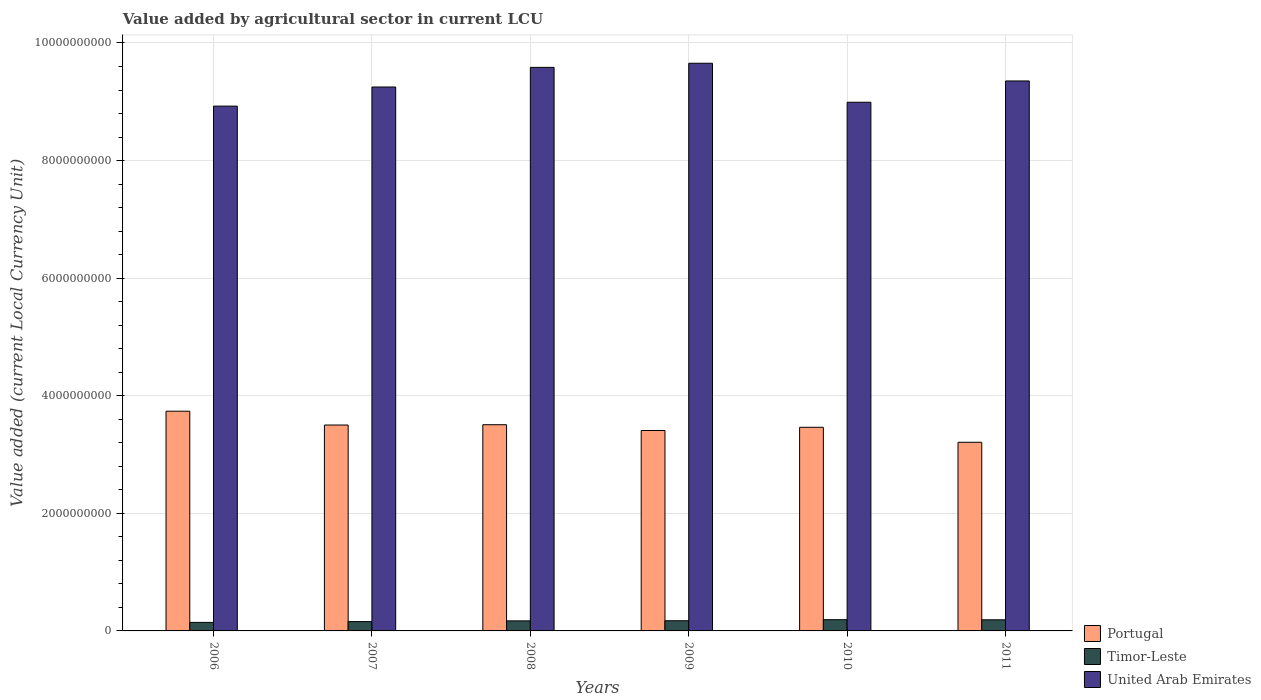How many different coloured bars are there?
Offer a terse response. 3. How many groups of bars are there?
Ensure brevity in your answer.  6. Are the number of bars per tick equal to the number of legend labels?
Ensure brevity in your answer.  Yes. Are the number of bars on each tick of the X-axis equal?
Give a very brief answer. Yes. What is the value added by agricultural sector in Portugal in 2009?
Offer a terse response. 3.41e+09. Across all years, what is the maximum value added by agricultural sector in Timor-Leste?
Make the answer very short. 1.91e+08. Across all years, what is the minimum value added by agricultural sector in Timor-Leste?
Make the answer very short. 1.45e+08. In which year was the value added by agricultural sector in United Arab Emirates maximum?
Give a very brief answer. 2009. What is the total value added by agricultural sector in Portugal in the graph?
Give a very brief answer. 2.08e+1. What is the difference between the value added by agricultural sector in Timor-Leste in 2007 and that in 2010?
Provide a succinct answer. -3.20e+07. What is the difference between the value added by agricultural sector in Timor-Leste in 2008 and the value added by agricultural sector in United Arab Emirates in 2009?
Give a very brief answer. -9.48e+09. What is the average value added by agricultural sector in United Arab Emirates per year?
Provide a short and direct response. 9.29e+09. In the year 2006, what is the difference between the value added by agricultural sector in Timor-Leste and value added by agricultural sector in Portugal?
Provide a short and direct response. -3.59e+09. In how many years, is the value added by agricultural sector in Timor-Leste greater than 2000000000 LCU?
Your response must be concise. 0. What is the ratio of the value added by agricultural sector in Portugal in 2007 to that in 2010?
Your response must be concise. 1.01. Is the difference between the value added by agricultural sector in Timor-Leste in 2006 and 2010 greater than the difference between the value added by agricultural sector in Portugal in 2006 and 2010?
Keep it short and to the point. No. What is the difference between the highest and the second highest value added by agricultural sector in United Arab Emirates?
Offer a terse response. 7.00e+07. What is the difference between the highest and the lowest value added by agricultural sector in United Arab Emirates?
Offer a terse response. 7.29e+08. What does the 3rd bar from the left in 2008 represents?
Your answer should be compact. United Arab Emirates. What does the 1st bar from the right in 2009 represents?
Keep it short and to the point. United Arab Emirates. Is it the case that in every year, the sum of the value added by agricultural sector in Timor-Leste and value added by agricultural sector in United Arab Emirates is greater than the value added by agricultural sector in Portugal?
Provide a succinct answer. Yes. How many years are there in the graph?
Provide a short and direct response. 6. Where does the legend appear in the graph?
Your answer should be very brief. Bottom right. How many legend labels are there?
Give a very brief answer. 3. What is the title of the graph?
Your answer should be very brief. Value added by agricultural sector in current LCU. What is the label or title of the X-axis?
Provide a short and direct response. Years. What is the label or title of the Y-axis?
Offer a terse response. Value added (current Local Currency Unit). What is the Value added (current Local Currency Unit) of Portugal in 2006?
Provide a short and direct response. 3.74e+09. What is the Value added (current Local Currency Unit) of Timor-Leste in 2006?
Provide a succinct answer. 1.45e+08. What is the Value added (current Local Currency Unit) in United Arab Emirates in 2006?
Provide a short and direct response. 8.93e+09. What is the Value added (current Local Currency Unit) in Portugal in 2007?
Keep it short and to the point. 3.50e+09. What is the Value added (current Local Currency Unit) of Timor-Leste in 2007?
Your response must be concise. 1.59e+08. What is the Value added (current Local Currency Unit) of United Arab Emirates in 2007?
Provide a succinct answer. 9.25e+09. What is the Value added (current Local Currency Unit) of Portugal in 2008?
Your answer should be very brief. 3.51e+09. What is the Value added (current Local Currency Unit) of Timor-Leste in 2008?
Provide a succinct answer. 1.71e+08. What is the Value added (current Local Currency Unit) of United Arab Emirates in 2008?
Your answer should be compact. 9.58e+09. What is the Value added (current Local Currency Unit) of Portugal in 2009?
Provide a succinct answer. 3.41e+09. What is the Value added (current Local Currency Unit) of Timor-Leste in 2009?
Ensure brevity in your answer.  1.73e+08. What is the Value added (current Local Currency Unit) in United Arab Emirates in 2009?
Your response must be concise. 9.66e+09. What is the Value added (current Local Currency Unit) of Portugal in 2010?
Offer a terse response. 3.46e+09. What is the Value added (current Local Currency Unit) in Timor-Leste in 2010?
Ensure brevity in your answer.  1.91e+08. What is the Value added (current Local Currency Unit) of United Arab Emirates in 2010?
Offer a terse response. 8.99e+09. What is the Value added (current Local Currency Unit) of Portugal in 2011?
Offer a terse response. 3.21e+09. What is the Value added (current Local Currency Unit) in Timor-Leste in 2011?
Provide a succinct answer. 1.89e+08. What is the Value added (current Local Currency Unit) in United Arab Emirates in 2011?
Your response must be concise. 9.35e+09. Across all years, what is the maximum Value added (current Local Currency Unit) in Portugal?
Your answer should be compact. 3.74e+09. Across all years, what is the maximum Value added (current Local Currency Unit) of Timor-Leste?
Keep it short and to the point. 1.91e+08. Across all years, what is the maximum Value added (current Local Currency Unit) of United Arab Emirates?
Your response must be concise. 9.66e+09. Across all years, what is the minimum Value added (current Local Currency Unit) of Portugal?
Ensure brevity in your answer.  3.21e+09. Across all years, what is the minimum Value added (current Local Currency Unit) in Timor-Leste?
Keep it short and to the point. 1.45e+08. Across all years, what is the minimum Value added (current Local Currency Unit) in United Arab Emirates?
Your answer should be compact. 8.93e+09. What is the total Value added (current Local Currency Unit) of Portugal in the graph?
Offer a very short reply. 2.08e+1. What is the total Value added (current Local Currency Unit) in Timor-Leste in the graph?
Ensure brevity in your answer.  1.03e+09. What is the total Value added (current Local Currency Unit) of United Arab Emirates in the graph?
Provide a succinct answer. 5.58e+1. What is the difference between the Value added (current Local Currency Unit) of Portugal in 2006 and that in 2007?
Your answer should be very brief. 2.35e+08. What is the difference between the Value added (current Local Currency Unit) of Timor-Leste in 2006 and that in 2007?
Provide a succinct answer. -1.40e+07. What is the difference between the Value added (current Local Currency Unit) in United Arab Emirates in 2006 and that in 2007?
Your answer should be compact. -3.25e+08. What is the difference between the Value added (current Local Currency Unit) of Portugal in 2006 and that in 2008?
Offer a terse response. 2.29e+08. What is the difference between the Value added (current Local Currency Unit) in Timor-Leste in 2006 and that in 2008?
Your answer should be compact. -2.60e+07. What is the difference between the Value added (current Local Currency Unit) in United Arab Emirates in 2006 and that in 2008?
Your answer should be very brief. -6.59e+08. What is the difference between the Value added (current Local Currency Unit) in Portugal in 2006 and that in 2009?
Your answer should be compact. 3.28e+08. What is the difference between the Value added (current Local Currency Unit) in Timor-Leste in 2006 and that in 2009?
Offer a terse response. -2.80e+07. What is the difference between the Value added (current Local Currency Unit) in United Arab Emirates in 2006 and that in 2009?
Your answer should be compact. -7.29e+08. What is the difference between the Value added (current Local Currency Unit) of Portugal in 2006 and that in 2010?
Keep it short and to the point. 2.73e+08. What is the difference between the Value added (current Local Currency Unit) of Timor-Leste in 2006 and that in 2010?
Ensure brevity in your answer.  -4.60e+07. What is the difference between the Value added (current Local Currency Unit) in United Arab Emirates in 2006 and that in 2010?
Offer a terse response. -6.60e+07. What is the difference between the Value added (current Local Currency Unit) of Portugal in 2006 and that in 2011?
Give a very brief answer. 5.28e+08. What is the difference between the Value added (current Local Currency Unit) in Timor-Leste in 2006 and that in 2011?
Your response must be concise. -4.40e+07. What is the difference between the Value added (current Local Currency Unit) in United Arab Emirates in 2006 and that in 2011?
Provide a succinct answer. -4.28e+08. What is the difference between the Value added (current Local Currency Unit) of Portugal in 2007 and that in 2008?
Your answer should be compact. -5.42e+06. What is the difference between the Value added (current Local Currency Unit) of Timor-Leste in 2007 and that in 2008?
Your answer should be very brief. -1.20e+07. What is the difference between the Value added (current Local Currency Unit) of United Arab Emirates in 2007 and that in 2008?
Your response must be concise. -3.34e+08. What is the difference between the Value added (current Local Currency Unit) in Portugal in 2007 and that in 2009?
Your answer should be very brief. 9.31e+07. What is the difference between the Value added (current Local Currency Unit) in Timor-Leste in 2007 and that in 2009?
Your response must be concise. -1.40e+07. What is the difference between the Value added (current Local Currency Unit) in United Arab Emirates in 2007 and that in 2009?
Make the answer very short. -4.04e+08. What is the difference between the Value added (current Local Currency Unit) in Portugal in 2007 and that in 2010?
Provide a short and direct response. 3.86e+07. What is the difference between the Value added (current Local Currency Unit) in Timor-Leste in 2007 and that in 2010?
Ensure brevity in your answer.  -3.20e+07. What is the difference between the Value added (current Local Currency Unit) of United Arab Emirates in 2007 and that in 2010?
Your response must be concise. 2.59e+08. What is the difference between the Value added (current Local Currency Unit) in Portugal in 2007 and that in 2011?
Provide a short and direct response. 2.93e+08. What is the difference between the Value added (current Local Currency Unit) of Timor-Leste in 2007 and that in 2011?
Ensure brevity in your answer.  -3.00e+07. What is the difference between the Value added (current Local Currency Unit) of United Arab Emirates in 2007 and that in 2011?
Offer a terse response. -1.03e+08. What is the difference between the Value added (current Local Currency Unit) in Portugal in 2008 and that in 2009?
Give a very brief answer. 9.85e+07. What is the difference between the Value added (current Local Currency Unit) in Timor-Leste in 2008 and that in 2009?
Offer a terse response. -2.00e+06. What is the difference between the Value added (current Local Currency Unit) in United Arab Emirates in 2008 and that in 2009?
Your answer should be very brief. -7.00e+07. What is the difference between the Value added (current Local Currency Unit) in Portugal in 2008 and that in 2010?
Offer a terse response. 4.40e+07. What is the difference between the Value added (current Local Currency Unit) in Timor-Leste in 2008 and that in 2010?
Keep it short and to the point. -2.00e+07. What is the difference between the Value added (current Local Currency Unit) in United Arab Emirates in 2008 and that in 2010?
Your answer should be very brief. 5.93e+08. What is the difference between the Value added (current Local Currency Unit) in Portugal in 2008 and that in 2011?
Make the answer very short. 2.99e+08. What is the difference between the Value added (current Local Currency Unit) in Timor-Leste in 2008 and that in 2011?
Give a very brief answer. -1.80e+07. What is the difference between the Value added (current Local Currency Unit) in United Arab Emirates in 2008 and that in 2011?
Your answer should be very brief. 2.31e+08. What is the difference between the Value added (current Local Currency Unit) of Portugal in 2009 and that in 2010?
Provide a succinct answer. -5.45e+07. What is the difference between the Value added (current Local Currency Unit) in Timor-Leste in 2009 and that in 2010?
Offer a terse response. -1.80e+07. What is the difference between the Value added (current Local Currency Unit) of United Arab Emirates in 2009 and that in 2010?
Keep it short and to the point. 6.63e+08. What is the difference between the Value added (current Local Currency Unit) of Portugal in 2009 and that in 2011?
Keep it short and to the point. 2.00e+08. What is the difference between the Value added (current Local Currency Unit) of Timor-Leste in 2009 and that in 2011?
Keep it short and to the point. -1.60e+07. What is the difference between the Value added (current Local Currency Unit) of United Arab Emirates in 2009 and that in 2011?
Make the answer very short. 3.01e+08. What is the difference between the Value added (current Local Currency Unit) in Portugal in 2010 and that in 2011?
Make the answer very short. 2.55e+08. What is the difference between the Value added (current Local Currency Unit) in United Arab Emirates in 2010 and that in 2011?
Your response must be concise. -3.62e+08. What is the difference between the Value added (current Local Currency Unit) in Portugal in 2006 and the Value added (current Local Currency Unit) in Timor-Leste in 2007?
Make the answer very short. 3.58e+09. What is the difference between the Value added (current Local Currency Unit) in Portugal in 2006 and the Value added (current Local Currency Unit) in United Arab Emirates in 2007?
Give a very brief answer. -5.51e+09. What is the difference between the Value added (current Local Currency Unit) of Timor-Leste in 2006 and the Value added (current Local Currency Unit) of United Arab Emirates in 2007?
Ensure brevity in your answer.  -9.11e+09. What is the difference between the Value added (current Local Currency Unit) in Portugal in 2006 and the Value added (current Local Currency Unit) in Timor-Leste in 2008?
Provide a succinct answer. 3.57e+09. What is the difference between the Value added (current Local Currency Unit) of Portugal in 2006 and the Value added (current Local Currency Unit) of United Arab Emirates in 2008?
Ensure brevity in your answer.  -5.85e+09. What is the difference between the Value added (current Local Currency Unit) in Timor-Leste in 2006 and the Value added (current Local Currency Unit) in United Arab Emirates in 2008?
Give a very brief answer. -9.44e+09. What is the difference between the Value added (current Local Currency Unit) in Portugal in 2006 and the Value added (current Local Currency Unit) in Timor-Leste in 2009?
Your answer should be very brief. 3.56e+09. What is the difference between the Value added (current Local Currency Unit) in Portugal in 2006 and the Value added (current Local Currency Unit) in United Arab Emirates in 2009?
Offer a very short reply. -5.92e+09. What is the difference between the Value added (current Local Currency Unit) in Timor-Leste in 2006 and the Value added (current Local Currency Unit) in United Arab Emirates in 2009?
Keep it short and to the point. -9.51e+09. What is the difference between the Value added (current Local Currency Unit) in Portugal in 2006 and the Value added (current Local Currency Unit) in Timor-Leste in 2010?
Offer a terse response. 3.55e+09. What is the difference between the Value added (current Local Currency Unit) in Portugal in 2006 and the Value added (current Local Currency Unit) in United Arab Emirates in 2010?
Your answer should be very brief. -5.26e+09. What is the difference between the Value added (current Local Currency Unit) in Timor-Leste in 2006 and the Value added (current Local Currency Unit) in United Arab Emirates in 2010?
Make the answer very short. -8.85e+09. What is the difference between the Value added (current Local Currency Unit) in Portugal in 2006 and the Value added (current Local Currency Unit) in Timor-Leste in 2011?
Your answer should be compact. 3.55e+09. What is the difference between the Value added (current Local Currency Unit) of Portugal in 2006 and the Value added (current Local Currency Unit) of United Arab Emirates in 2011?
Offer a terse response. -5.62e+09. What is the difference between the Value added (current Local Currency Unit) in Timor-Leste in 2006 and the Value added (current Local Currency Unit) in United Arab Emirates in 2011?
Offer a very short reply. -9.21e+09. What is the difference between the Value added (current Local Currency Unit) of Portugal in 2007 and the Value added (current Local Currency Unit) of Timor-Leste in 2008?
Keep it short and to the point. 3.33e+09. What is the difference between the Value added (current Local Currency Unit) of Portugal in 2007 and the Value added (current Local Currency Unit) of United Arab Emirates in 2008?
Your answer should be very brief. -6.08e+09. What is the difference between the Value added (current Local Currency Unit) in Timor-Leste in 2007 and the Value added (current Local Currency Unit) in United Arab Emirates in 2008?
Your answer should be compact. -9.43e+09. What is the difference between the Value added (current Local Currency Unit) in Portugal in 2007 and the Value added (current Local Currency Unit) in Timor-Leste in 2009?
Give a very brief answer. 3.33e+09. What is the difference between the Value added (current Local Currency Unit) in Portugal in 2007 and the Value added (current Local Currency Unit) in United Arab Emirates in 2009?
Give a very brief answer. -6.15e+09. What is the difference between the Value added (current Local Currency Unit) of Timor-Leste in 2007 and the Value added (current Local Currency Unit) of United Arab Emirates in 2009?
Your response must be concise. -9.50e+09. What is the difference between the Value added (current Local Currency Unit) in Portugal in 2007 and the Value added (current Local Currency Unit) in Timor-Leste in 2010?
Give a very brief answer. 3.31e+09. What is the difference between the Value added (current Local Currency Unit) of Portugal in 2007 and the Value added (current Local Currency Unit) of United Arab Emirates in 2010?
Ensure brevity in your answer.  -5.49e+09. What is the difference between the Value added (current Local Currency Unit) of Timor-Leste in 2007 and the Value added (current Local Currency Unit) of United Arab Emirates in 2010?
Your answer should be very brief. -8.83e+09. What is the difference between the Value added (current Local Currency Unit) of Portugal in 2007 and the Value added (current Local Currency Unit) of Timor-Leste in 2011?
Keep it short and to the point. 3.31e+09. What is the difference between the Value added (current Local Currency Unit) of Portugal in 2007 and the Value added (current Local Currency Unit) of United Arab Emirates in 2011?
Offer a very short reply. -5.85e+09. What is the difference between the Value added (current Local Currency Unit) of Timor-Leste in 2007 and the Value added (current Local Currency Unit) of United Arab Emirates in 2011?
Provide a short and direct response. -9.20e+09. What is the difference between the Value added (current Local Currency Unit) of Portugal in 2008 and the Value added (current Local Currency Unit) of Timor-Leste in 2009?
Ensure brevity in your answer.  3.33e+09. What is the difference between the Value added (current Local Currency Unit) of Portugal in 2008 and the Value added (current Local Currency Unit) of United Arab Emirates in 2009?
Ensure brevity in your answer.  -6.15e+09. What is the difference between the Value added (current Local Currency Unit) in Timor-Leste in 2008 and the Value added (current Local Currency Unit) in United Arab Emirates in 2009?
Your answer should be very brief. -9.48e+09. What is the difference between the Value added (current Local Currency Unit) of Portugal in 2008 and the Value added (current Local Currency Unit) of Timor-Leste in 2010?
Offer a terse response. 3.32e+09. What is the difference between the Value added (current Local Currency Unit) of Portugal in 2008 and the Value added (current Local Currency Unit) of United Arab Emirates in 2010?
Your answer should be compact. -5.48e+09. What is the difference between the Value added (current Local Currency Unit) in Timor-Leste in 2008 and the Value added (current Local Currency Unit) in United Arab Emirates in 2010?
Your answer should be compact. -8.82e+09. What is the difference between the Value added (current Local Currency Unit) of Portugal in 2008 and the Value added (current Local Currency Unit) of Timor-Leste in 2011?
Your response must be concise. 3.32e+09. What is the difference between the Value added (current Local Currency Unit) in Portugal in 2008 and the Value added (current Local Currency Unit) in United Arab Emirates in 2011?
Your answer should be compact. -5.85e+09. What is the difference between the Value added (current Local Currency Unit) in Timor-Leste in 2008 and the Value added (current Local Currency Unit) in United Arab Emirates in 2011?
Your answer should be compact. -9.18e+09. What is the difference between the Value added (current Local Currency Unit) in Portugal in 2009 and the Value added (current Local Currency Unit) in Timor-Leste in 2010?
Your response must be concise. 3.22e+09. What is the difference between the Value added (current Local Currency Unit) in Portugal in 2009 and the Value added (current Local Currency Unit) in United Arab Emirates in 2010?
Offer a very short reply. -5.58e+09. What is the difference between the Value added (current Local Currency Unit) in Timor-Leste in 2009 and the Value added (current Local Currency Unit) in United Arab Emirates in 2010?
Provide a succinct answer. -8.82e+09. What is the difference between the Value added (current Local Currency Unit) of Portugal in 2009 and the Value added (current Local Currency Unit) of Timor-Leste in 2011?
Make the answer very short. 3.22e+09. What is the difference between the Value added (current Local Currency Unit) in Portugal in 2009 and the Value added (current Local Currency Unit) in United Arab Emirates in 2011?
Your answer should be very brief. -5.95e+09. What is the difference between the Value added (current Local Currency Unit) in Timor-Leste in 2009 and the Value added (current Local Currency Unit) in United Arab Emirates in 2011?
Your response must be concise. -9.18e+09. What is the difference between the Value added (current Local Currency Unit) in Portugal in 2010 and the Value added (current Local Currency Unit) in Timor-Leste in 2011?
Make the answer very short. 3.27e+09. What is the difference between the Value added (current Local Currency Unit) in Portugal in 2010 and the Value added (current Local Currency Unit) in United Arab Emirates in 2011?
Provide a succinct answer. -5.89e+09. What is the difference between the Value added (current Local Currency Unit) in Timor-Leste in 2010 and the Value added (current Local Currency Unit) in United Arab Emirates in 2011?
Your answer should be compact. -9.16e+09. What is the average Value added (current Local Currency Unit) of Portugal per year?
Your answer should be very brief. 3.47e+09. What is the average Value added (current Local Currency Unit) of Timor-Leste per year?
Your response must be concise. 1.71e+08. What is the average Value added (current Local Currency Unit) of United Arab Emirates per year?
Keep it short and to the point. 9.29e+09. In the year 2006, what is the difference between the Value added (current Local Currency Unit) in Portugal and Value added (current Local Currency Unit) in Timor-Leste?
Offer a terse response. 3.59e+09. In the year 2006, what is the difference between the Value added (current Local Currency Unit) in Portugal and Value added (current Local Currency Unit) in United Arab Emirates?
Make the answer very short. -5.19e+09. In the year 2006, what is the difference between the Value added (current Local Currency Unit) of Timor-Leste and Value added (current Local Currency Unit) of United Arab Emirates?
Offer a very short reply. -8.78e+09. In the year 2007, what is the difference between the Value added (current Local Currency Unit) of Portugal and Value added (current Local Currency Unit) of Timor-Leste?
Your answer should be very brief. 3.34e+09. In the year 2007, what is the difference between the Value added (current Local Currency Unit) in Portugal and Value added (current Local Currency Unit) in United Arab Emirates?
Provide a succinct answer. -5.75e+09. In the year 2007, what is the difference between the Value added (current Local Currency Unit) of Timor-Leste and Value added (current Local Currency Unit) of United Arab Emirates?
Provide a short and direct response. -9.09e+09. In the year 2008, what is the difference between the Value added (current Local Currency Unit) of Portugal and Value added (current Local Currency Unit) of Timor-Leste?
Offer a terse response. 3.34e+09. In the year 2008, what is the difference between the Value added (current Local Currency Unit) of Portugal and Value added (current Local Currency Unit) of United Arab Emirates?
Offer a terse response. -6.08e+09. In the year 2008, what is the difference between the Value added (current Local Currency Unit) of Timor-Leste and Value added (current Local Currency Unit) of United Arab Emirates?
Offer a terse response. -9.41e+09. In the year 2009, what is the difference between the Value added (current Local Currency Unit) of Portugal and Value added (current Local Currency Unit) of Timor-Leste?
Your answer should be compact. 3.24e+09. In the year 2009, what is the difference between the Value added (current Local Currency Unit) of Portugal and Value added (current Local Currency Unit) of United Arab Emirates?
Offer a very short reply. -6.25e+09. In the year 2009, what is the difference between the Value added (current Local Currency Unit) in Timor-Leste and Value added (current Local Currency Unit) in United Arab Emirates?
Your answer should be very brief. -9.48e+09. In the year 2010, what is the difference between the Value added (current Local Currency Unit) of Portugal and Value added (current Local Currency Unit) of Timor-Leste?
Provide a short and direct response. 3.27e+09. In the year 2010, what is the difference between the Value added (current Local Currency Unit) in Portugal and Value added (current Local Currency Unit) in United Arab Emirates?
Give a very brief answer. -5.53e+09. In the year 2010, what is the difference between the Value added (current Local Currency Unit) of Timor-Leste and Value added (current Local Currency Unit) of United Arab Emirates?
Ensure brevity in your answer.  -8.80e+09. In the year 2011, what is the difference between the Value added (current Local Currency Unit) of Portugal and Value added (current Local Currency Unit) of Timor-Leste?
Provide a succinct answer. 3.02e+09. In the year 2011, what is the difference between the Value added (current Local Currency Unit) of Portugal and Value added (current Local Currency Unit) of United Arab Emirates?
Offer a very short reply. -6.15e+09. In the year 2011, what is the difference between the Value added (current Local Currency Unit) in Timor-Leste and Value added (current Local Currency Unit) in United Arab Emirates?
Make the answer very short. -9.16e+09. What is the ratio of the Value added (current Local Currency Unit) of Portugal in 2006 to that in 2007?
Make the answer very short. 1.07. What is the ratio of the Value added (current Local Currency Unit) of Timor-Leste in 2006 to that in 2007?
Keep it short and to the point. 0.91. What is the ratio of the Value added (current Local Currency Unit) of United Arab Emirates in 2006 to that in 2007?
Offer a terse response. 0.96. What is the ratio of the Value added (current Local Currency Unit) in Portugal in 2006 to that in 2008?
Offer a terse response. 1.07. What is the ratio of the Value added (current Local Currency Unit) of Timor-Leste in 2006 to that in 2008?
Your answer should be very brief. 0.85. What is the ratio of the Value added (current Local Currency Unit) in United Arab Emirates in 2006 to that in 2008?
Your response must be concise. 0.93. What is the ratio of the Value added (current Local Currency Unit) of Portugal in 2006 to that in 2009?
Offer a terse response. 1.1. What is the ratio of the Value added (current Local Currency Unit) in Timor-Leste in 2006 to that in 2009?
Keep it short and to the point. 0.84. What is the ratio of the Value added (current Local Currency Unit) of United Arab Emirates in 2006 to that in 2009?
Give a very brief answer. 0.92. What is the ratio of the Value added (current Local Currency Unit) of Portugal in 2006 to that in 2010?
Ensure brevity in your answer.  1.08. What is the ratio of the Value added (current Local Currency Unit) in Timor-Leste in 2006 to that in 2010?
Ensure brevity in your answer.  0.76. What is the ratio of the Value added (current Local Currency Unit) of United Arab Emirates in 2006 to that in 2010?
Offer a terse response. 0.99. What is the ratio of the Value added (current Local Currency Unit) of Portugal in 2006 to that in 2011?
Your answer should be very brief. 1.16. What is the ratio of the Value added (current Local Currency Unit) of Timor-Leste in 2006 to that in 2011?
Provide a short and direct response. 0.77. What is the ratio of the Value added (current Local Currency Unit) of United Arab Emirates in 2006 to that in 2011?
Keep it short and to the point. 0.95. What is the ratio of the Value added (current Local Currency Unit) of Timor-Leste in 2007 to that in 2008?
Make the answer very short. 0.93. What is the ratio of the Value added (current Local Currency Unit) in United Arab Emirates in 2007 to that in 2008?
Ensure brevity in your answer.  0.97. What is the ratio of the Value added (current Local Currency Unit) in Portugal in 2007 to that in 2009?
Provide a succinct answer. 1.03. What is the ratio of the Value added (current Local Currency Unit) in Timor-Leste in 2007 to that in 2009?
Make the answer very short. 0.92. What is the ratio of the Value added (current Local Currency Unit) in United Arab Emirates in 2007 to that in 2009?
Give a very brief answer. 0.96. What is the ratio of the Value added (current Local Currency Unit) in Portugal in 2007 to that in 2010?
Your answer should be very brief. 1.01. What is the ratio of the Value added (current Local Currency Unit) in Timor-Leste in 2007 to that in 2010?
Give a very brief answer. 0.83. What is the ratio of the Value added (current Local Currency Unit) in United Arab Emirates in 2007 to that in 2010?
Your response must be concise. 1.03. What is the ratio of the Value added (current Local Currency Unit) in Portugal in 2007 to that in 2011?
Provide a succinct answer. 1.09. What is the ratio of the Value added (current Local Currency Unit) of Timor-Leste in 2007 to that in 2011?
Keep it short and to the point. 0.84. What is the ratio of the Value added (current Local Currency Unit) in Portugal in 2008 to that in 2009?
Offer a terse response. 1.03. What is the ratio of the Value added (current Local Currency Unit) of Timor-Leste in 2008 to that in 2009?
Provide a short and direct response. 0.99. What is the ratio of the Value added (current Local Currency Unit) in United Arab Emirates in 2008 to that in 2009?
Offer a terse response. 0.99. What is the ratio of the Value added (current Local Currency Unit) in Portugal in 2008 to that in 2010?
Make the answer very short. 1.01. What is the ratio of the Value added (current Local Currency Unit) of Timor-Leste in 2008 to that in 2010?
Your response must be concise. 0.9. What is the ratio of the Value added (current Local Currency Unit) in United Arab Emirates in 2008 to that in 2010?
Give a very brief answer. 1.07. What is the ratio of the Value added (current Local Currency Unit) of Portugal in 2008 to that in 2011?
Your answer should be compact. 1.09. What is the ratio of the Value added (current Local Currency Unit) in Timor-Leste in 2008 to that in 2011?
Provide a succinct answer. 0.9. What is the ratio of the Value added (current Local Currency Unit) in United Arab Emirates in 2008 to that in 2011?
Your answer should be compact. 1.02. What is the ratio of the Value added (current Local Currency Unit) in Portugal in 2009 to that in 2010?
Provide a short and direct response. 0.98. What is the ratio of the Value added (current Local Currency Unit) of Timor-Leste in 2009 to that in 2010?
Keep it short and to the point. 0.91. What is the ratio of the Value added (current Local Currency Unit) in United Arab Emirates in 2009 to that in 2010?
Ensure brevity in your answer.  1.07. What is the ratio of the Value added (current Local Currency Unit) of Portugal in 2009 to that in 2011?
Give a very brief answer. 1.06. What is the ratio of the Value added (current Local Currency Unit) of Timor-Leste in 2009 to that in 2011?
Make the answer very short. 0.92. What is the ratio of the Value added (current Local Currency Unit) of United Arab Emirates in 2009 to that in 2011?
Make the answer very short. 1.03. What is the ratio of the Value added (current Local Currency Unit) in Portugal in 2010 to that in 2011?
Give a very brief answer. 1.08. What is the ratio of the Value added (current Local Currency Unit) of Timor-Leste in 2010 to that in 2011?
Provide a succinct answer. 1.01. What is the ratio of the Value added (current Local Currency Unit) of United Arab Emirates in 2010 to that in 2011?
Your answer should be compact. 0.96. What is the difference between the highest and the second highest Value added (current Local Currency Unit) in Portugal?
Give a very brief answer. 2.29e+08. What is the difference between the highest and the second highest Value added (current Local Currency Unit) of Timor-Leste?
Ensure brevity in your answer.  2.00e+06. What is the difference between the highest and the second highest Value added (current Local Currency Unit) in United Arab Emirates?
Make the answer very short. 7.00e+07. What is the difference between the highest and the lowest Value added (current Local Currency Unit) of Portugal?
Keep it short and to the point. 5.28e+08. What is the difference between the highest and the lowest Value added (current Local Currency Unit) in Timor-Leste?
Your answer should be very brief. 4.60e+07. What is the difference between the highest and the lowest Value added (current Local Currency Unit) of United Arab Emirates?
Your response must be concise. 7.29e+08. 